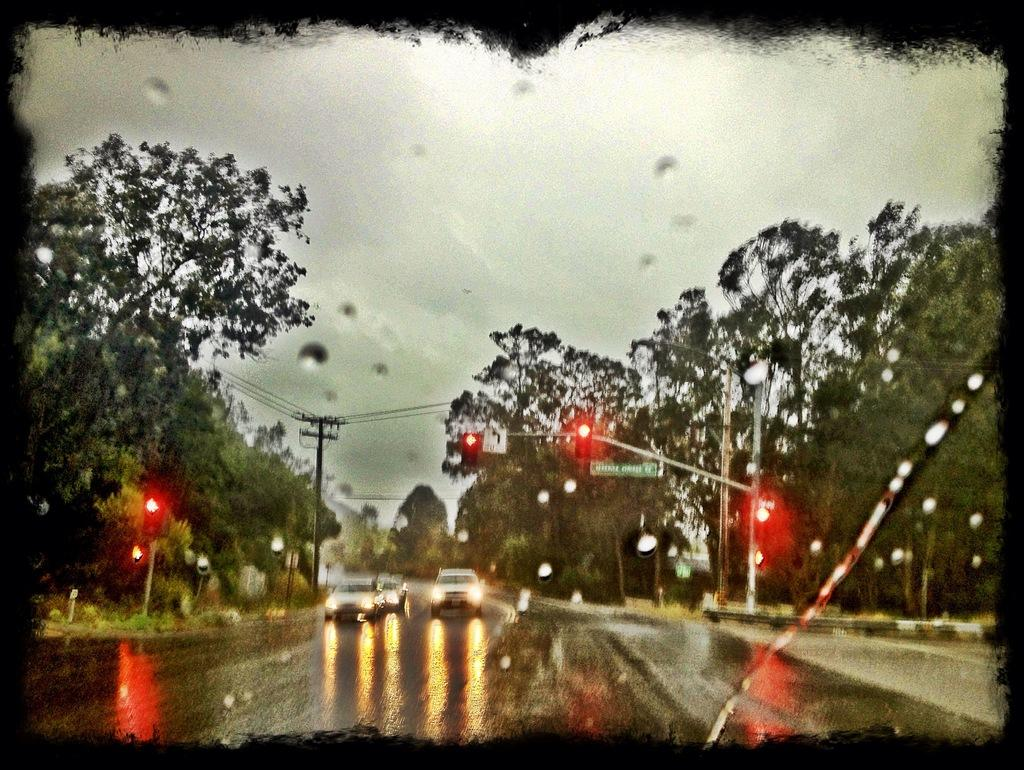What type of vehicles can be seen on the road in the image? There are cars on the road in the image. What natural elements are visible in the image? There are trees visible in the image. What traffic control devices are present in the image? There are traffic lights in the image. What utility infrastructure can be seen in the image? There is a utility pole with wires in the image. What type of sign or display is present in the image? There is a board in the image. How would you describe the weather based on the image? The sky is visible in the image and appears cloudy. What type of stone is being used to sing songs in the image? There is no stone or singing in the image; it features cars on the road, trees, traffic lights, a utility pole with wires, a board, and a cloudy sky. What type of cable is being used to connect the cars in the image? There is no cable connecting the cars in the image; they are moving independently on the road. 